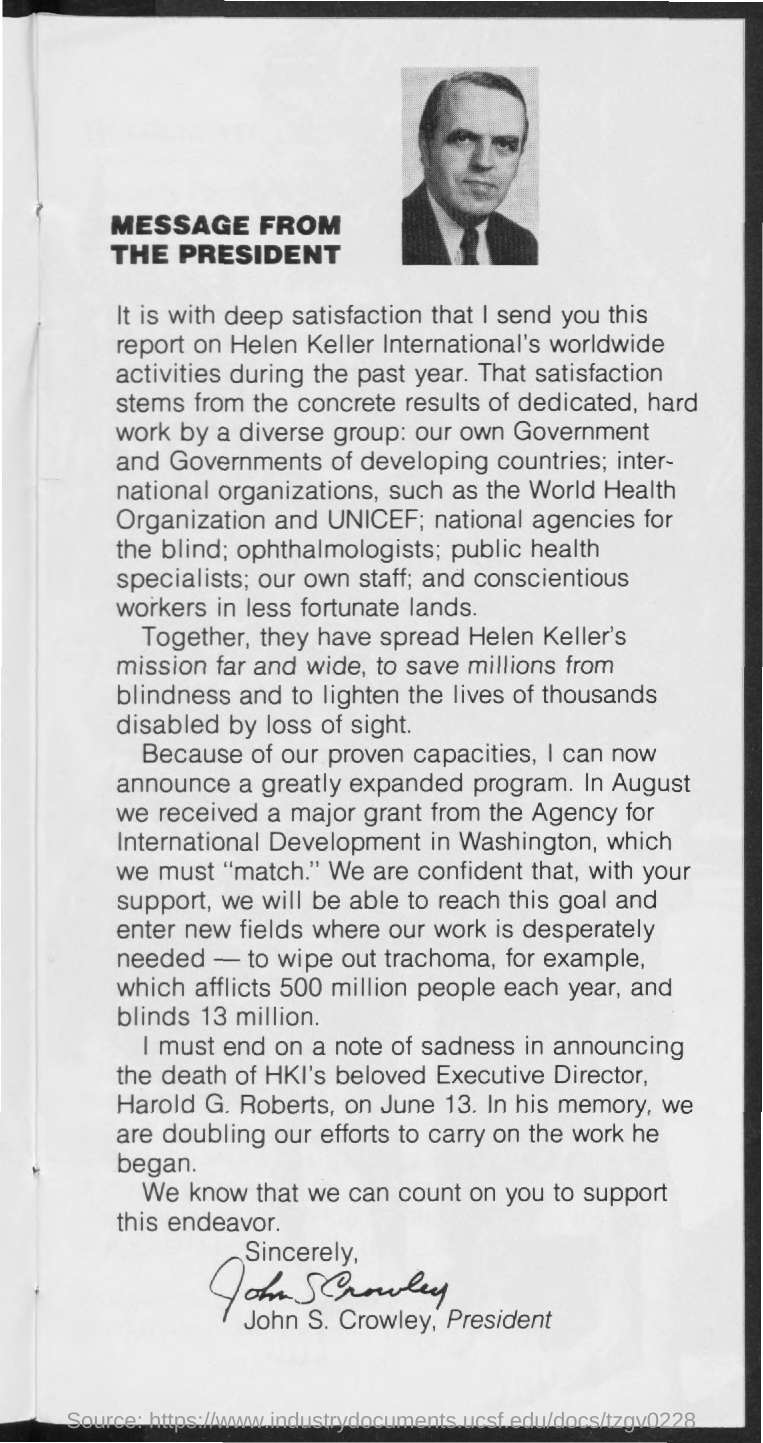Who has signed this document?
Provide a short and direct response. John S. Crowley. What is the main heading of the document?
Your answer should be very brief. Message from the president. 